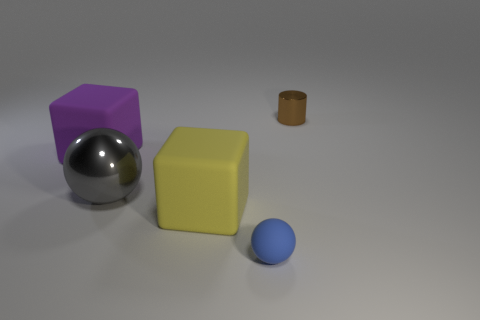There is a matte block in front of the big metal sphere; what color is it?
Make the answer very short. Yellow. Is the shape of the big gray object the same as the blue rubber object on the right side of the big metal sphere?
Offer a very short reply. Yes. The yellow block that is made of the same material as the small blue object is what size?
Provide a short and direct response. Large. There is a tiny object that is to the left of the brown cylinder; does it have the same shape as the gray metal thing?
Give a very brief answer. Yes. How many matte things have the same size as the gray shiny ball?
Give a very brief answer. 2. There is a ball left of the tiny blue sphere; are there any things to the right of it?
Keep it short and to the point. Yes. How many objects are either rubber things left of the yellow matte object or small blue balls?
Your answer should be compact. 2. What number of matte cubes are there?
Provide a succinct answer. 2. There is a gray object that is made of the same material as the brown object; what shape is it?
Your answer should be compact. Sphere. There is a shiny thing left of the sphere in front of the big yellow matte block; how big is it?
Offer a terse response. Large. 